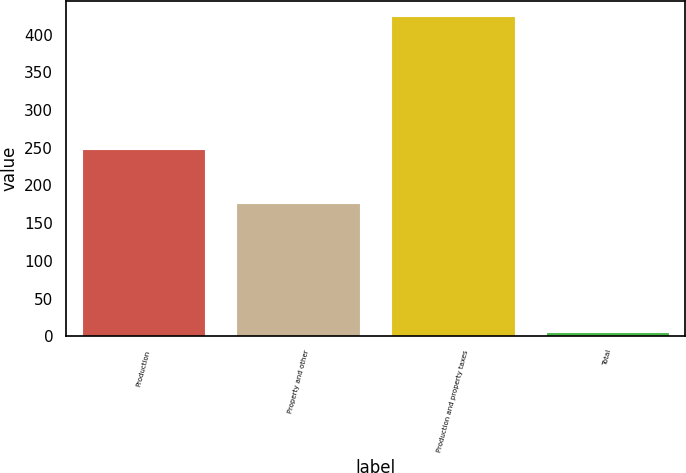<chart> <loc_0><loc_0><loc_500><loc_500><bar_chart><fcel>Production<fcel>Property and other<fcel>Production and property taxes<fcel>Total<nl><fcel>248<fcel>176<fcel>424<fcel>5.1<nl></chart> 